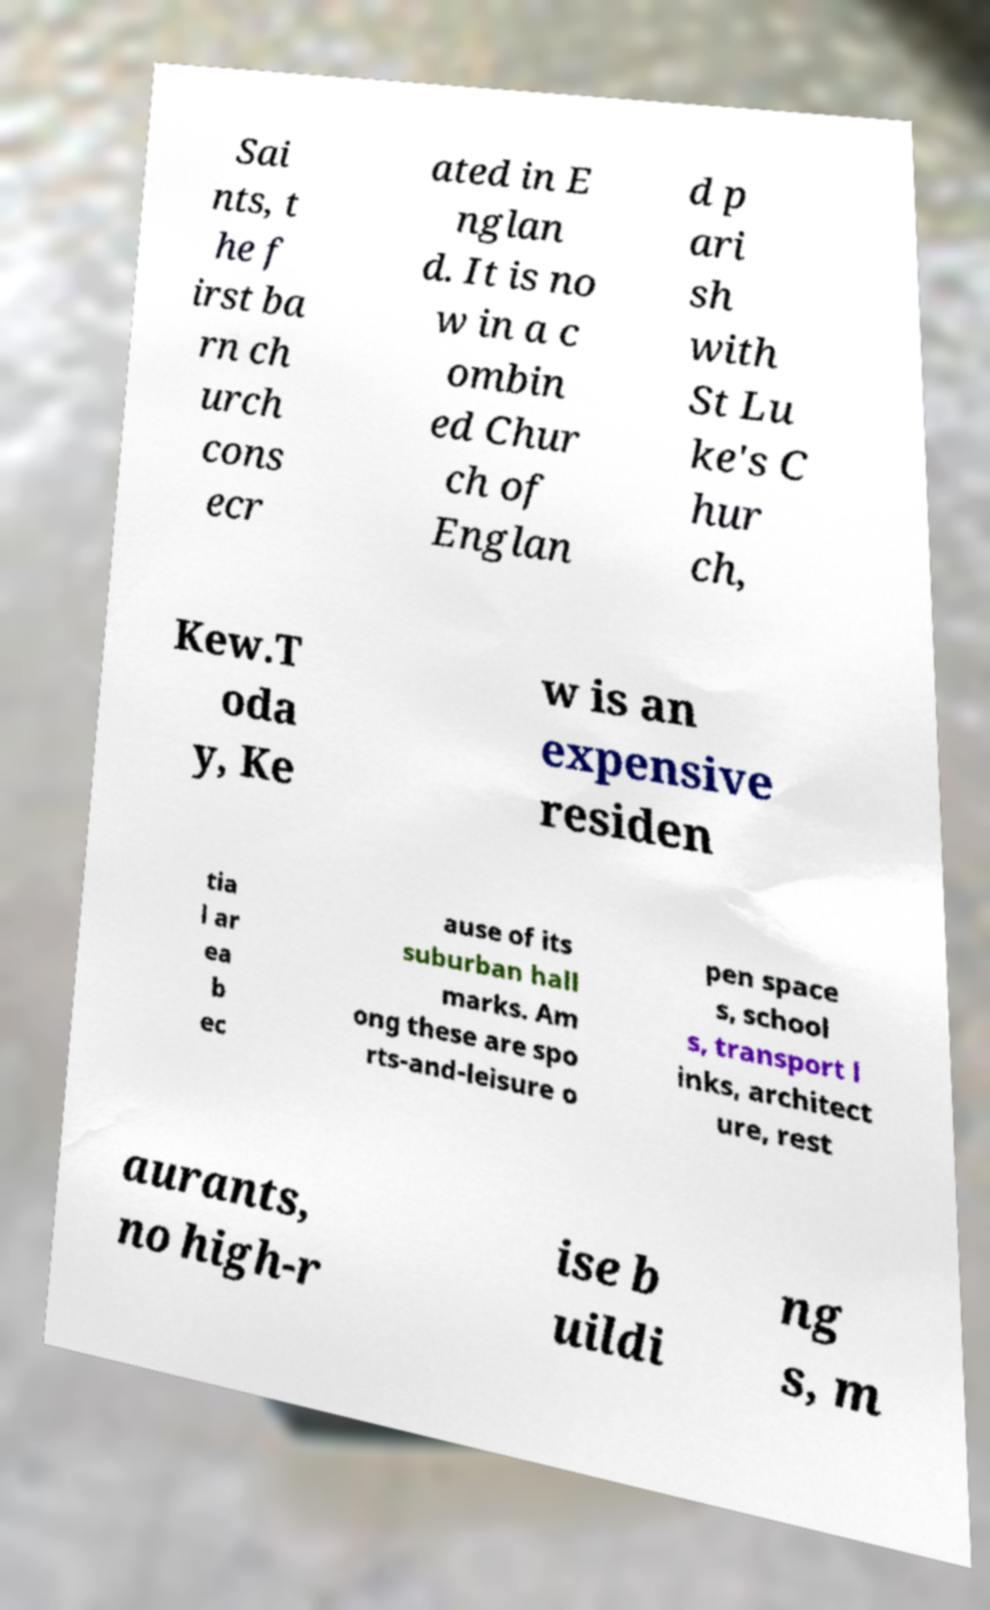Can you read and provide the text displayed in the image?This photo seems to have some interesting text. Can you extract and type it out for me? Sai nts, t he f irst ba rn ch urch cons ecr ated in E nglan d. It is no w in a c ombin ed Chur ch of Englan d p ari sh with St Lu ke's C hur ch, Kew.T oda y, Ke w is an expensive residen tia l ar ea b ec ause of its suburban hall marks. Am ong these are spo rts-and-leisure o pen space s, school s, transport l inks, architect ure, rest aurants, no high-r ise b uildi ng s, m 